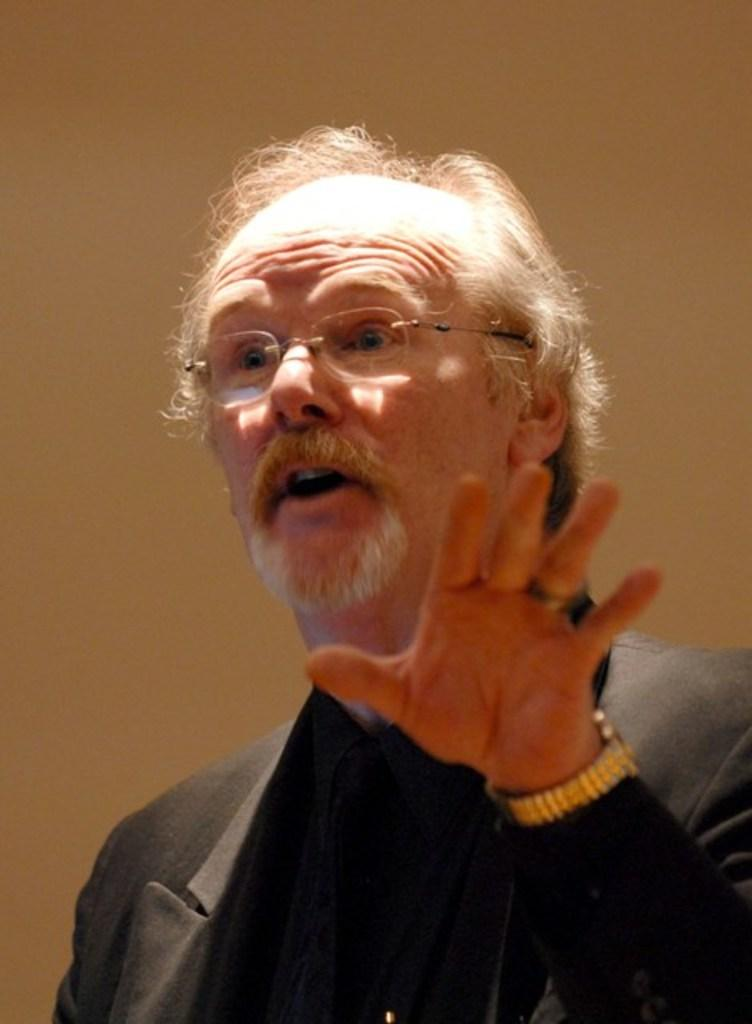What type of person is in the image? There is an old person in the image. What accessory is the old person wearing? The old person is wearing spectacles. What type of clothing is the old person wearing? The old person is wearing a suit. What is the old person doing in the image? The old person is talking. What type of support can be seen in the bedroom in the image? There is no bedroom or support present in the image; it features an old person talking while wearing spectacles and a suit. 